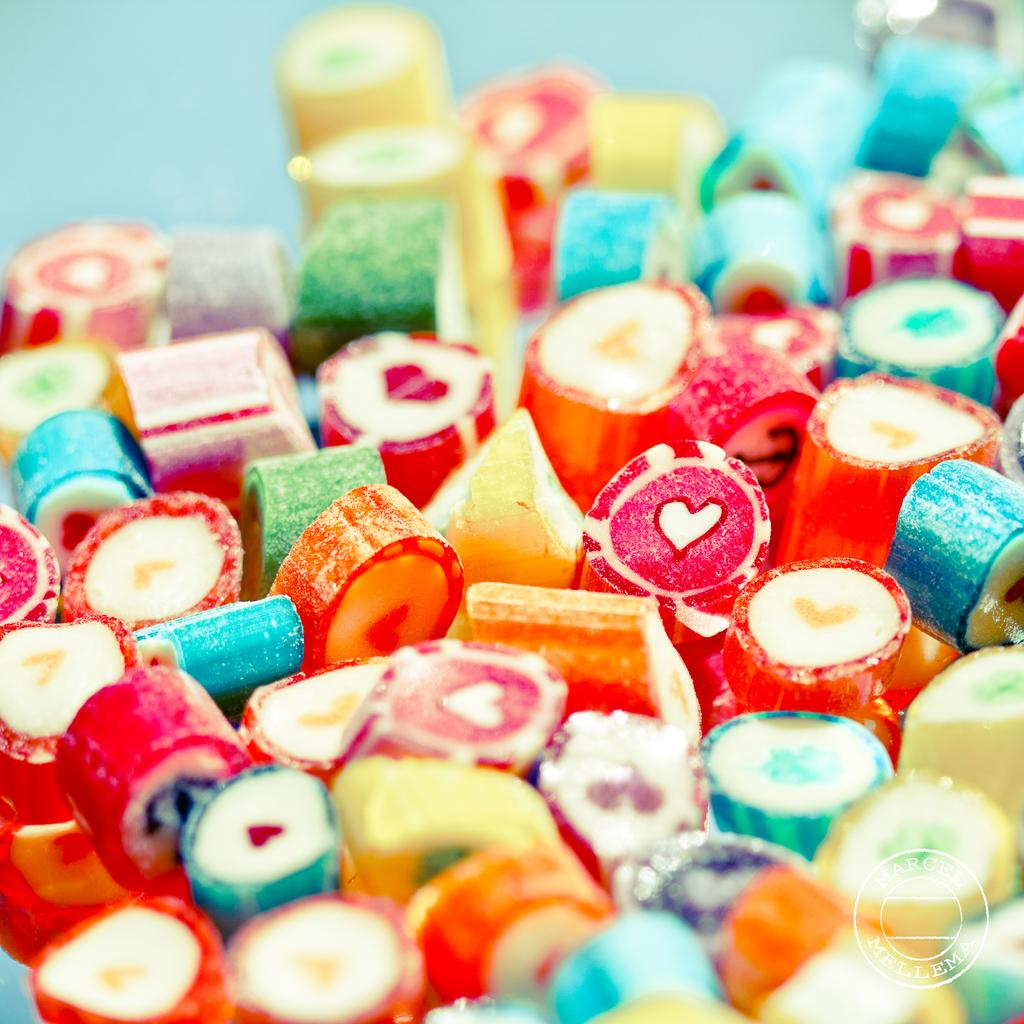What type of food is present in the image? There are candies in the image. Can you describe the appearance of the candies? The candies are of different colors. What type of shoes are the snails wearing in the image? There are no snails or shoes present in the image; it only features candies of different colors. 